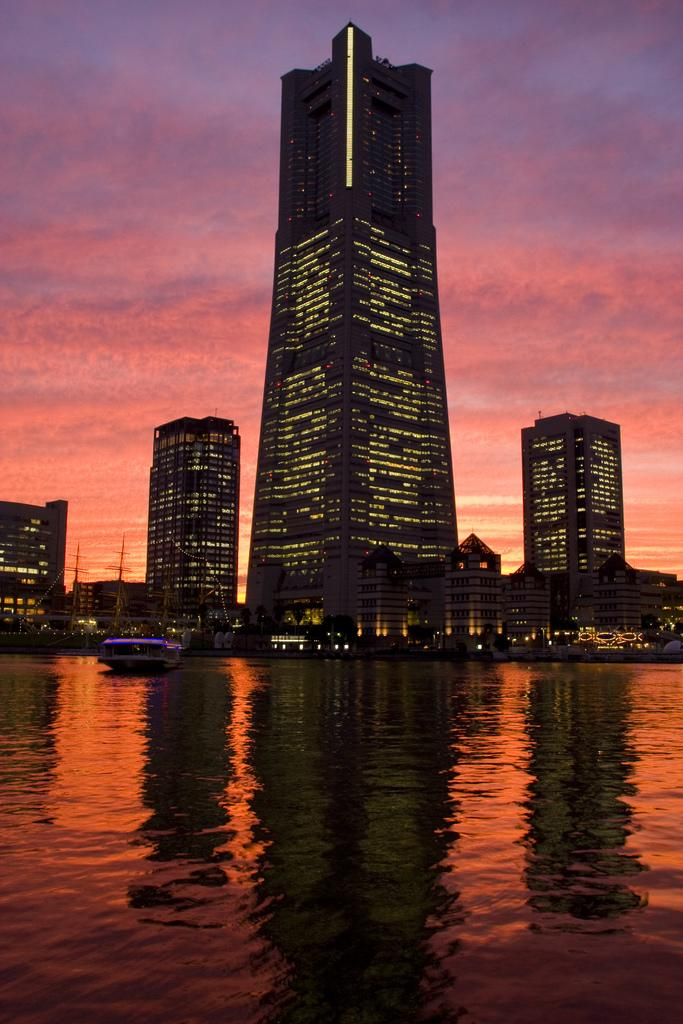What type of structures can be seen in the image? There are buildings in the image. What else can be seen in the image besides buildings? There are poles, a boat on the water, and lights visible in the image. Where is the boat located in the image? The boat is on the water in the image. What part of the natural environment is visible in the image? The sky is visible in the image. What type of skin can be seen on the quince in the image? There is no quince present in the image, and therefore no skin can be observed. 